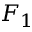<formula> <loc_0><loc_0><loc_500><loc_500>F _ { 1 }</formula> 